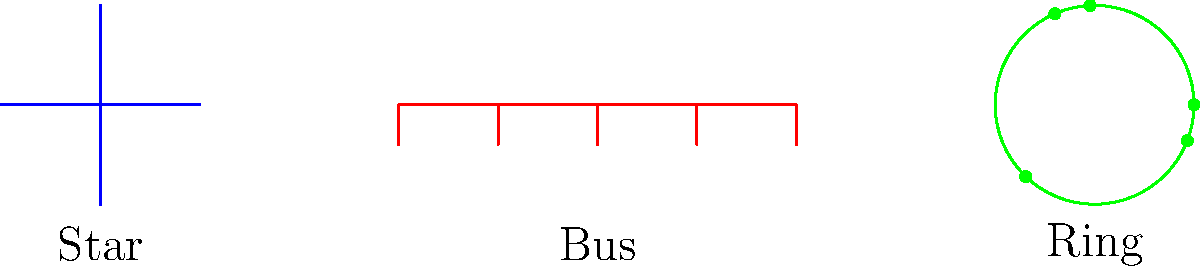As a project manager overseeing multiple network projects, you need to choose the most suitable network topology for a multi-site project with 5 locations. Consider factors such as scalability, fault tolerance, and ease of management. Which topology (star, bus, or ring) would be most appropriate, and why? To determine the most suitable topology for a multi-site project with 5 locations, let's analyze each topology:

1. Star Topology:
   - Centralized management: All sites connect to a central hub.
   - Scalability: Easy to add new sites by connecting to the central hub.
   - Fault tolerance: If one link fails, other sites remain connected.
   - Performance: Direct communication between central hub and sites.

2. Bus Topology:
   - Linear structure: All sites connect to a single cable.
   - Scalability: Limited, as adding sites increases network traffic.
   - Fault tolerance: A single cable failure can disrupt the entire network.
   - Performance: Can degrade with increased network traffic.

3. Ring Topology:
   - Circular structure: Each site connects to two adjacent sites.
   - Scalability: Moderate, requires reconfiguration when adding sites.
   - Fault tolerance: Can use dual ring for redundancy, but complex.
   - Performance: Data must pass through multiple sites, potentially causing delays.

Considering these factors:

1. Scalability: Star topology is the most scalable, allowing easy addition of new sites.
2. Fault tolerance: Star topology offers better fault isolation compared to bus and ring.
3. Ease of management: Star topology provides centralized management, simplifying troubleshooting and maintenance.
4. Performance: Star topology ensures direct communication between the central hub and sites, minimizing delays.

For a multi-site project with 5 locations, the star topology offers the best balance of scalability, fault tolerance, and ease of management.
Answer: Star topology 